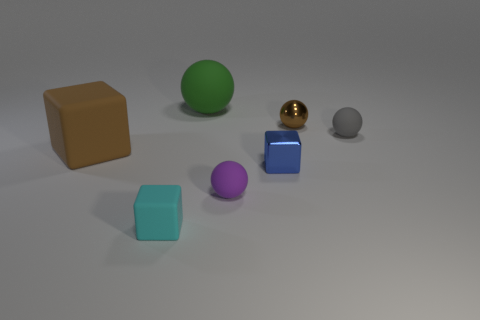Is there any other thing that has the same color as the big matte ball?
Ensure brevity in your answer.  No. There is a tiny matte object left of the big object that is behind the brown object that is right of the cyan object; what is its shape?
Provide a short and direct response. Cube. What color is the other large thing that is the same shape as the purple matte thing?
Keep it short and to the point. Green. The small object to the left of the large thing that is behind the gray ball is what color?
Offer a very short reply. Cyan. There is a green thing that is the same shape as the brown metal object; what size is it?
Offer a terse response. Large. How many objects have the same material as the large sphere?
Your answer should be compact. 4. How many purple rubber things are in front of the cyan thing in front of the blue thing?
Give a very brief answer. 0. There is a green thing; are there any tiny blue objects on the left side of it?
Your answer should be very brief. No. There is a brown object that is in front of the tiny gray matte sphere; is its shape the same as the blue metal thing?
Keep it short and to the point. Yes. There is a cube that is the same color as the metal ball; what material is it?
Offer a very short reply. Rubber. 